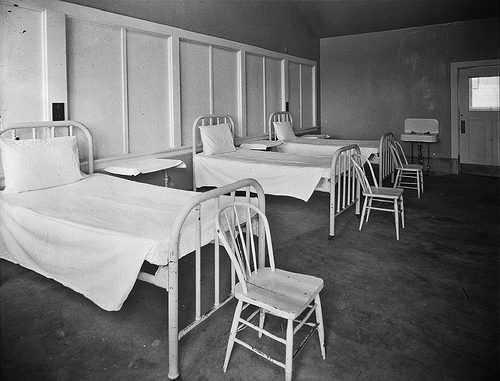Can you describe the condition and atmosphere of the room? The room appears stark and sparsely furnished, conveying a sense of simplicity or possibly neglect. The beds are neatly made with white linens, and the chairs are arranged tidily, yet the room feels empty and devoid of personal touches or comforts. It has an air of quiet and isolation that was typical in many institutional settings of the past. 